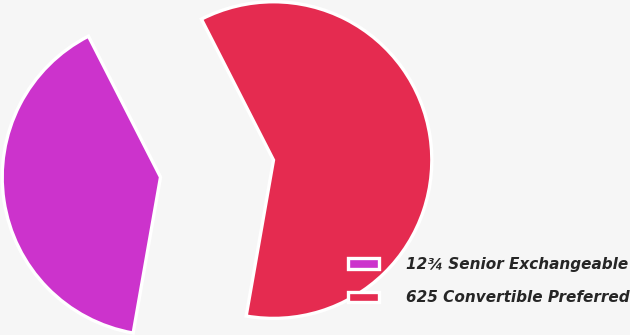Convert chart. <chart><loc_0><loc_0><loc_500><loc_500><pie_chart><fcel>12¾ Senior Exchangeable<fcel>625 Convertible Preferred<nl><fcel>39.71%<fcel>60.29%<nl></chart> 